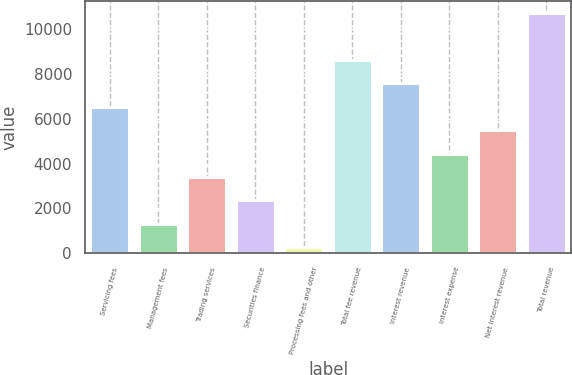<chart> <loc_0><loc_0><loc_500><loc_500><bar_chart><fcel>Servicing fees<fcel>Management fees<fcel>Trading services<fcel>Securities finance<fcel>Processing fees and other<fcel>Total fee revenue<fcel>Interest revenue<fcel>Interest expense<fcel>Net interest revenue<fcel>Total revenue<nl><fcel>6526.6<fcel>1318.6<fcel>3401.8<fcel>2360.2<fcel>277<fcel>8609.8<fcel>7568.2<fcel>4443.4<fcel>5485<fcel>10693<nl></chart> 